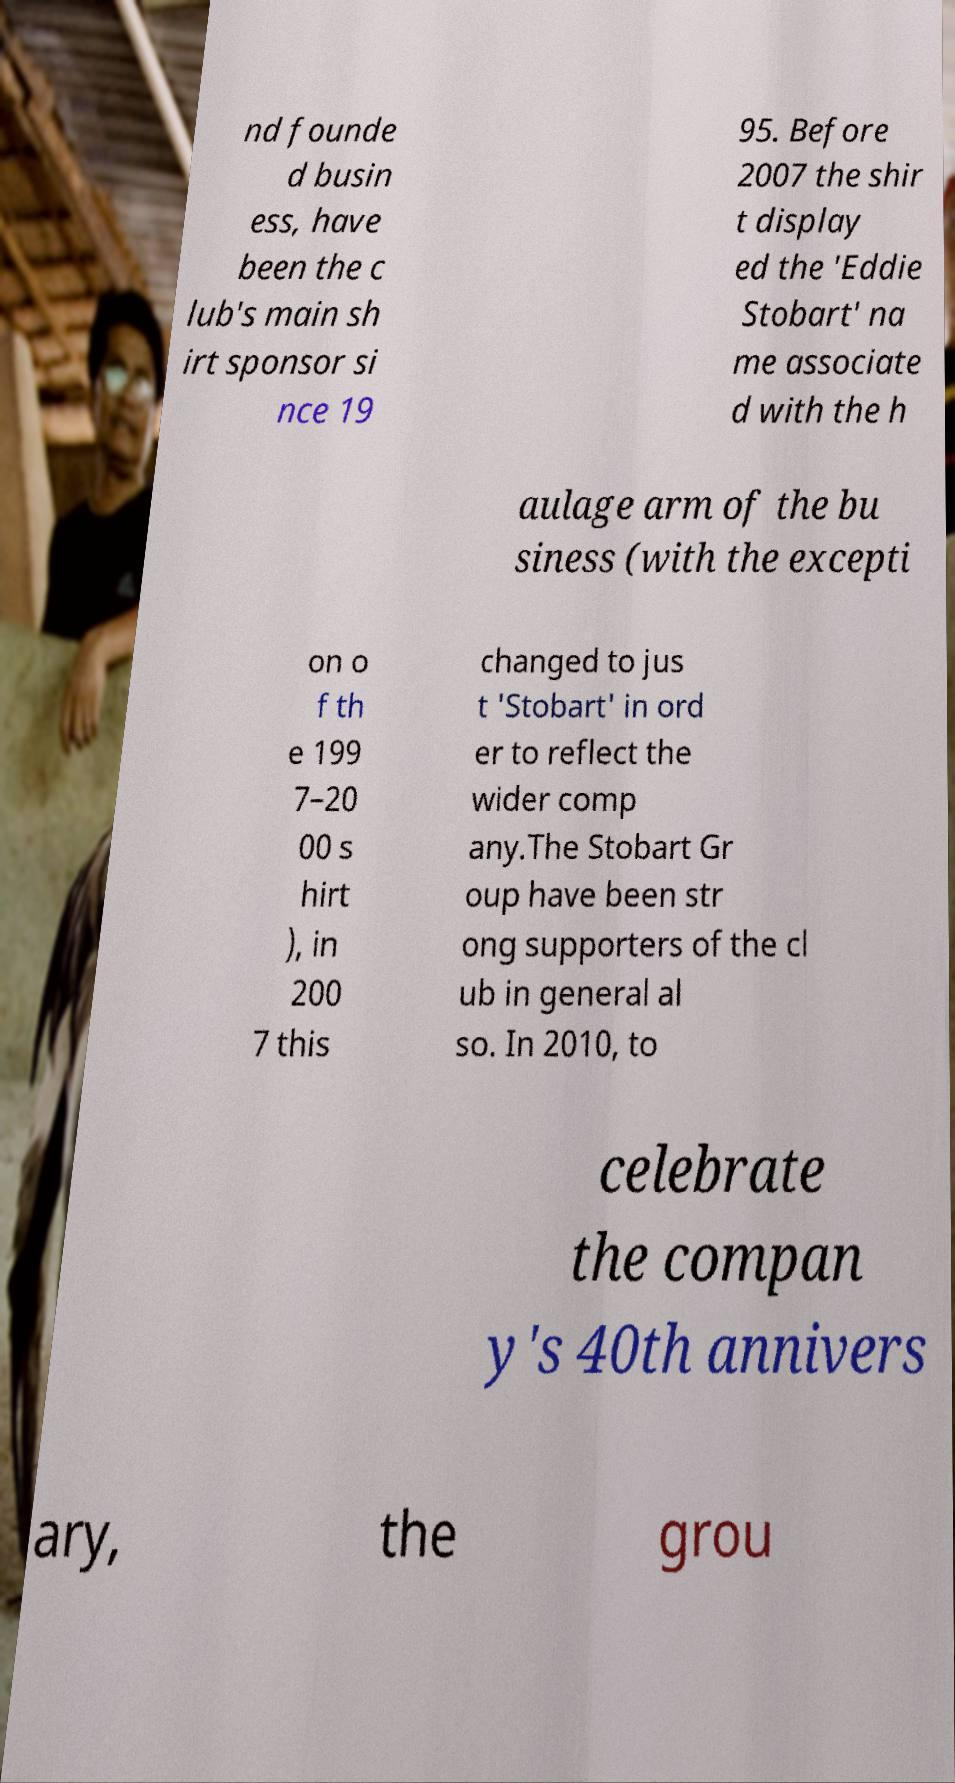What messages or text are displayed in this image? I need them in a readable, typed format. nd founde d busin ess, have been the c lub's main sh irt sponsor si nce 19 95. Before 2007 the shir t display ed the 'Eddie Stobart' na me associate d with the h aulage arm of the bu siness (with the excepti on o f th e 199 7–20 00 s hirt ), in 200 7 this changed to jus t 'Stobart' in ord er to reflect the wider comp any.The Stobart Gr oup have been str ong supporters of the cl ub in general al so. In 2010, to celebrate the compan y's 40th annivers ary, the grou 